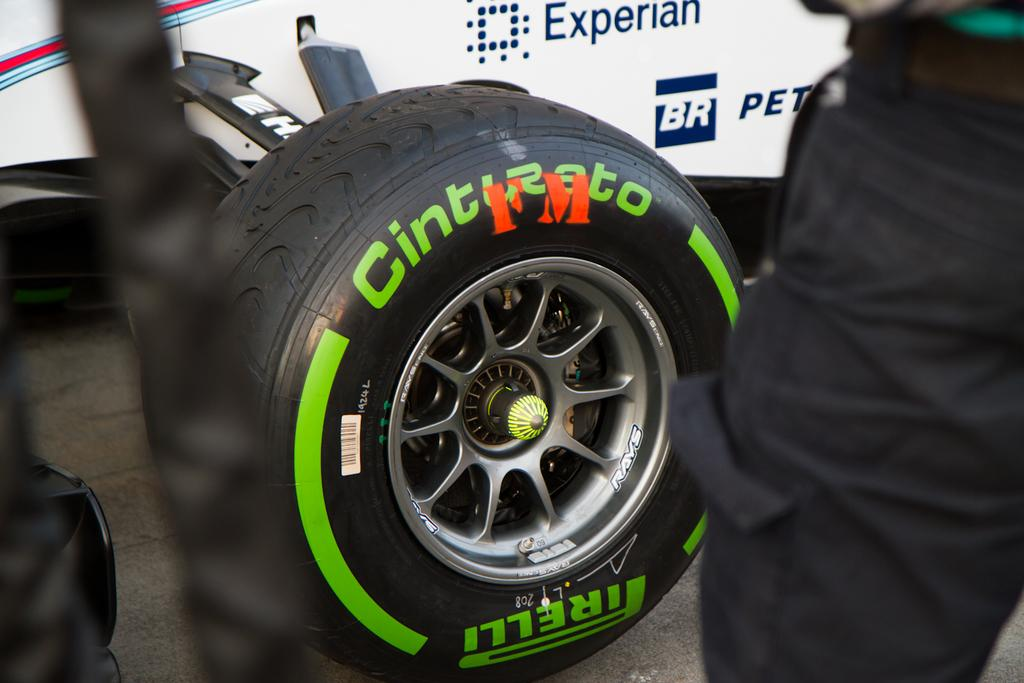What is the main subject of the image? The main subject of the image is a wheel of a heavy vehicle. Can you describe anything else in the image besides the wheel? Yes, there is a person on the right side of the image. What can be said about the person's appearance in the image? The person's face is not visible in the image. What type of thread is being used to sew the hill in the image? There is no thread or hill present in the image. 